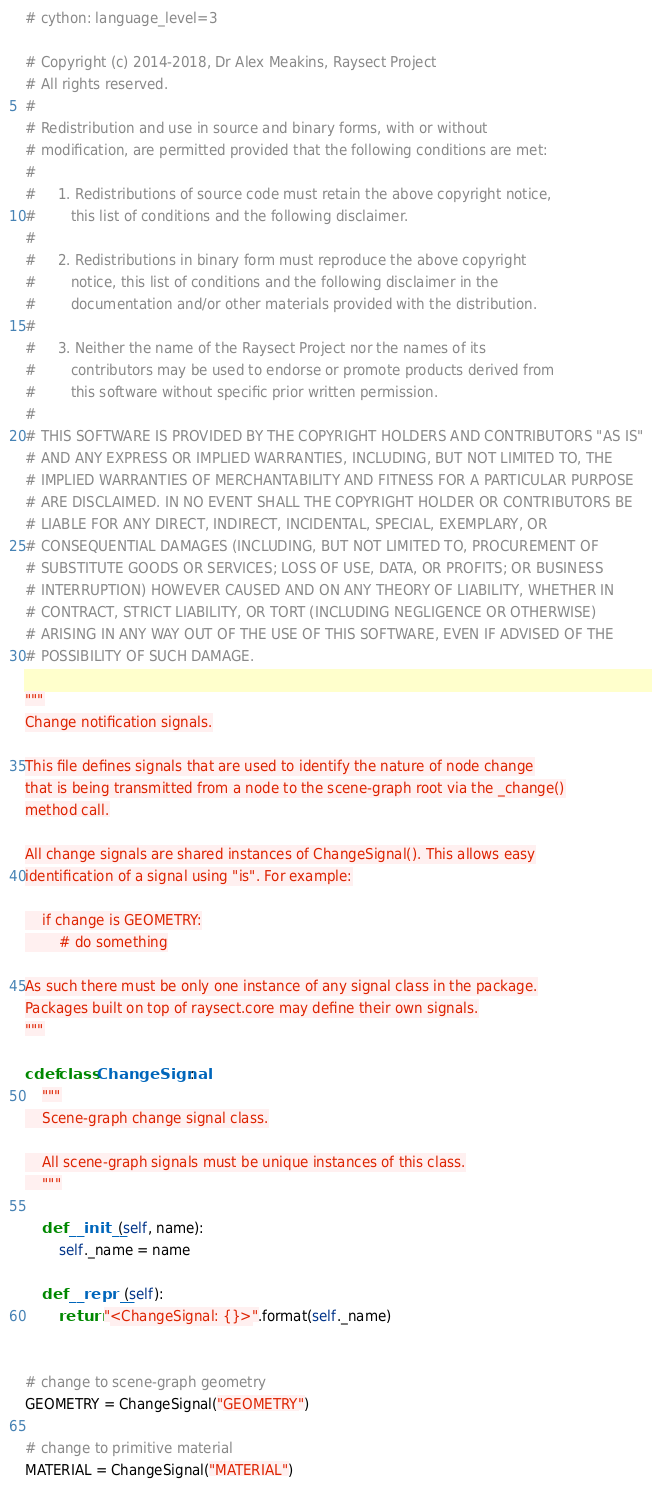Convert code to text. <code><loc_0><loc_0><loc_500><loc_500><_Cython_># cython: language_level=3

# Copyright (c) 2014-2018, Dr Alex Meakins, Raysect Project
# All rights reserved.
#
# Redistribution and use in source and binary forms, with or without
# modification, are permitted provided that the following conditions are met:
#
#     1. Redistributions of source code must retain the above copyright notice,
#        this list of conditions and the following disclaimer.
#
#     2. Redistributions in binary form must reproduce the above copyright
#        notice, this list of conditions and the following disclaimer in the
#        documentation and/or other materials provided with the distribution.
#
#     3. Neither the name of the Raysect Project nor the names of its
#        contributors may be used to endorse or promote products derived from
#        this software without specific prior written permission.
#
# THIS SOFTWARE IS PROVIDED BY THE COPYRIGHT HOLDERS AND CONTRIBUTORS "AS IS"
# AND ANY EXPRESS OR IMPLIED WARRANTIES, INCLUDING, BUT NOT LIMITED TO, THE
# IMPLIED WARRANTIES OF MERCHANTABILITY AND FITNESS FOR A PARTICULAR PURPOSE
# ARE DISCLAIMED. IN NO EVENT SHALL THE COPYRIGHT HOLDER OR CONTRIBUTORS BE
# LIABLE FOR ANY DIRECT, INDIRECT, INCIDENTAL, SPECIAL, EXEMPLARY, OR
# CONSEQUENTIAL DAMAGES (INCLUDING, BUT NOT LIMITED TO, PROCUREMENT OF
# SUBSTITUTE GOODS OR SERVICES; LOSS OF USE, DATA, OR PROFITS; OR BUSINESS
# INTERRUPTION) HOWEVER CAUSED AND ON ANY THEORY OF LIABILITY, WHETHER IN
# CONTRACT, STRICT LIABILITY, OR TORT (INCLUDING NEGLIGENCE OR OTHERWISE)
# ARISING IN ANY WAY OUT OF THE USE OF THIS SOFTWARE, EVEN IF ADVISED OF THE
# POSSIBILITY OF SUCH DAMAGE.

"""
Change notification signals.

This file defines signals that are used to identify the nature of node change
that is being transmitted from a node to the scene-graph root via the _change()
method call.

All change signals are shared instances of ChangeSignal(). This allows easy
identification of a signal using "is". For example:

    if change is GEOMETRY:
        # do something

As such there must be only one instance of any signal class in the package.
Packages built on top of raysect.core may define their own signals.
"""

cdef class ChangeSignal:
    """
    Scene-graph change signal class.

    All scene-graph signals must be unique instances of this class.
    """

    def __init__(self, name):
        self._name = name

    def __repr__(self):
        return "<ChangeSignal: {}>".format(self._name)


# change to scene-graph geometry
GEOMETRY = ChangeSignal("GEOMETRY")

# change to primitive material
MATERIAL = ChangeSignal("MATERIAL")



</code> 